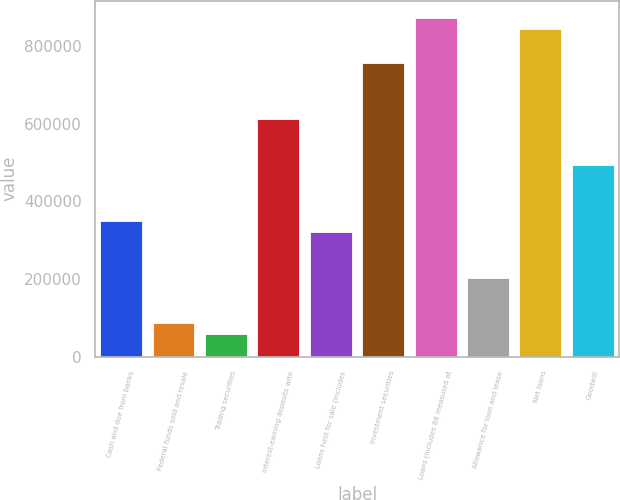Convert chart. <chart><loc_0><loc_0><loc_500><loc_500><bar_chart><fcel>Cash and due from banks<fcel>Federal funds sold and resale<fcel>Trading securities<fcel>Interest-earning deposits with<fcel>Loans held for sale (includes<fcel>Investment securities<fcel>Loans (includes 88 measured at<fcel>Allowance for loan and lease<fcel>Net loans<fcel>Goodwill<nl><fcel>349228<fcel>87565.1<fcel>58491.4<fcel>610892<fcel>320155<fcel>756260<fcel>872555<fcel>203860<fcel>843481<fcel>494597<nl></chart> 